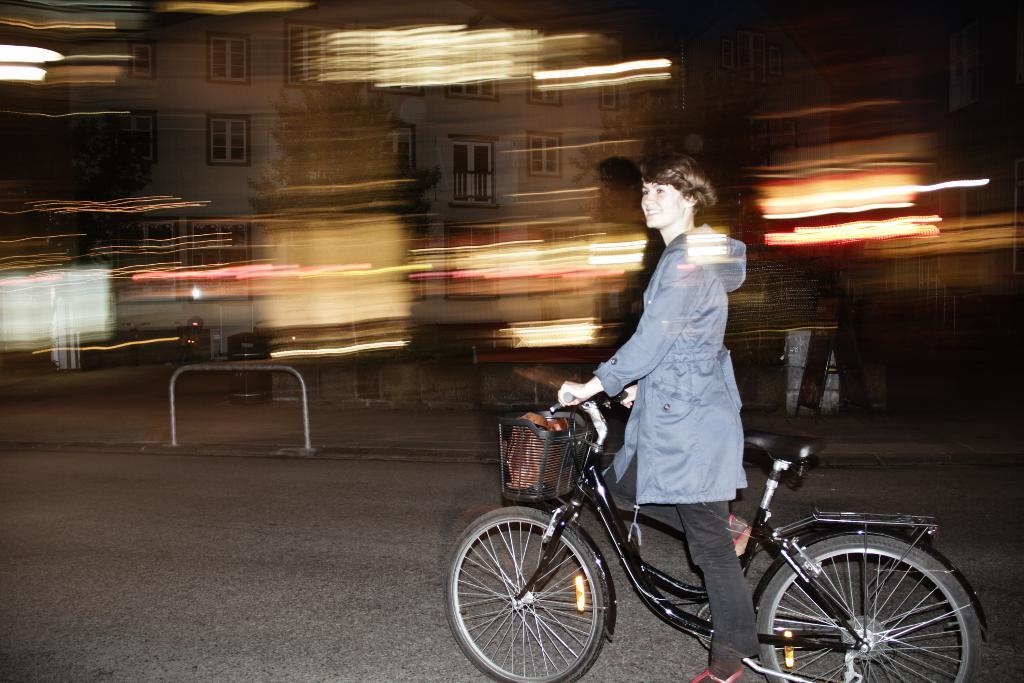Who is the main subject in the image? There is a woman in the image. What is the woman doing in the image? The woman is riding a bicycle. When was the image taken? The image is taken during night time. Where was the image taken? The image is taken on the road. What can be seen in the background of the image? There are buildings and trees visible in the background. What is the size of the test that the woman is conducting in the image? There is no test being conducted in the image; the woman is simply riding a bicycle. 